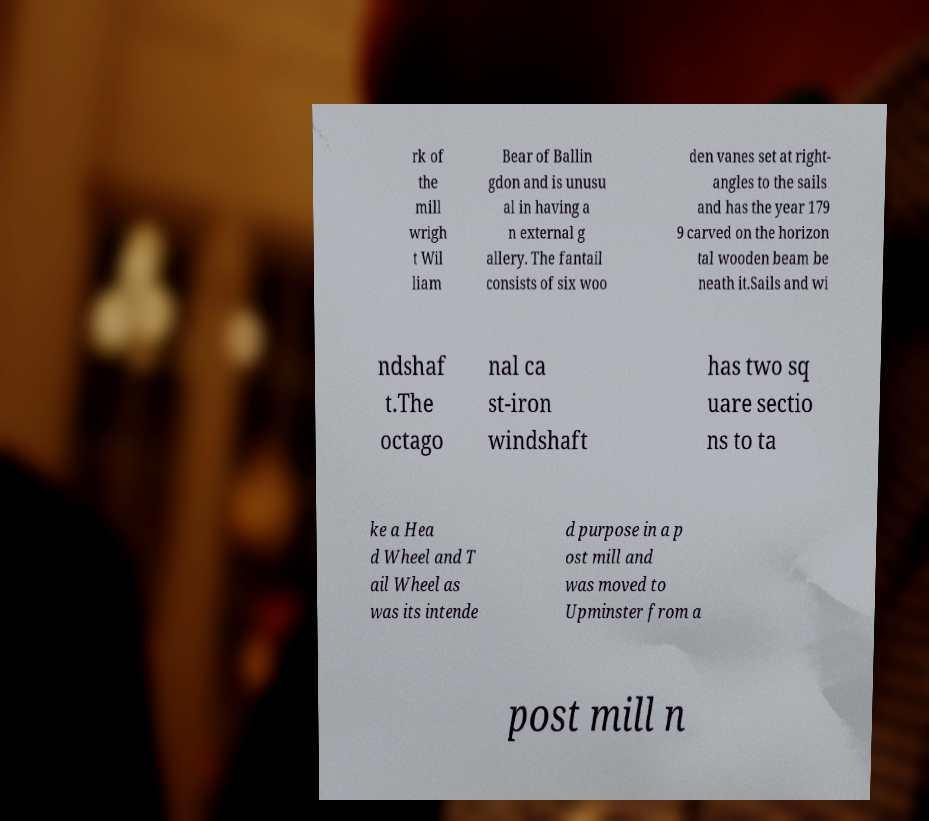There's text embedded in this image that I need extracted. Can you transcribe it verbatim? rk of the mill wrigh t Wil liam Bear of Ballin gdon and is unusu al in having a n external g allery. The fantail consists of six woo den vanes set at right- angles to the sails and has the year 179 9 carved on the horizon tal wooden beam be neath it.Sails and wi ndshaf t.The octago nal ca st-iron windshaft has two sq uare sectio ns to ta ke a Hea d Wheel and T ail Wheel as was its intende d purpose in a p ost mill and was moved to Upminster from a post mill n 